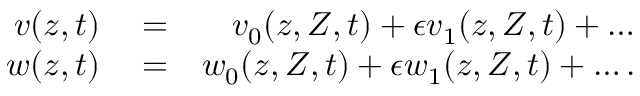<formula> <loc_0><loc_0><loc_500><loc_500>\begin{array} { r l r } { v ( z , t ) } & = } & { v _ { 0 } ( z , Z , t ) + \epsilon v _ { 1 } ( z , Z , t ) + \dots } \\ { w ( z , t ) } & = } & { w _ { 0 } ( z , Z , t ) + \epsilon w _ { 1 } ( z , Z , t ) + \dots . } \end{array}</formula> 